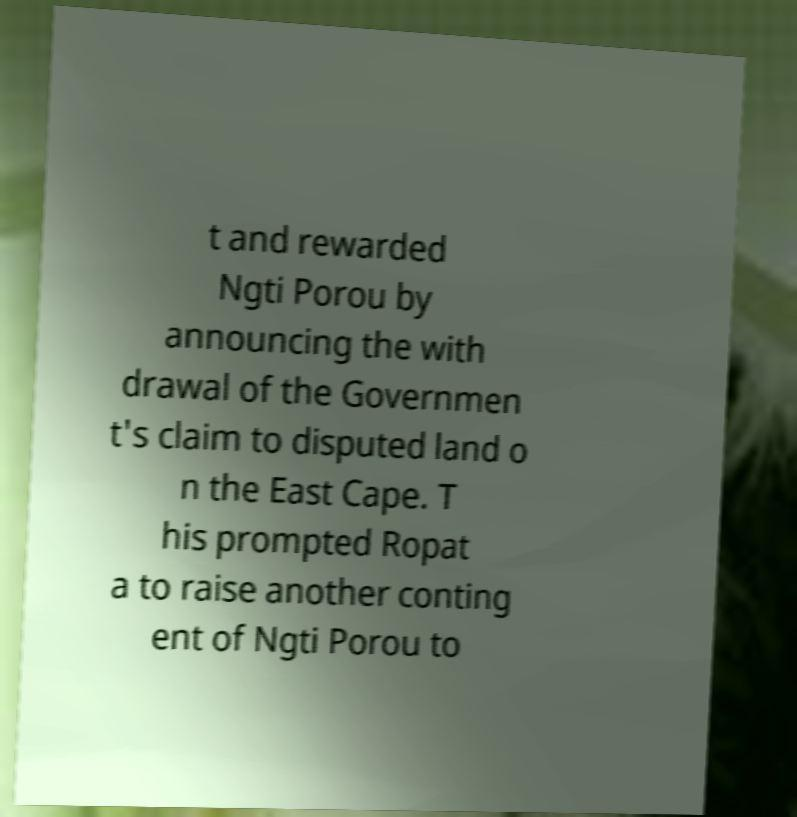Could you assist in decoding the text presented in this image and type it out clearly? t and rewarded Ngti Porou by announcing the with drawal of the Governmen t's claim to disputed land o n the East Cape. T his prompted Ropat a to raise another conting ent of Ngti Porou to 